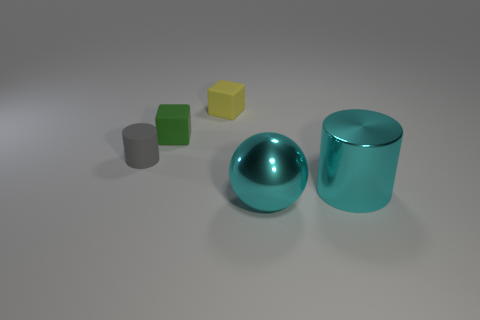The object that is to the right of the big cyan metallic object that is in front of the cylinder in front of the gray cylinder is what color?
Give a very brief answer. Cyan. Is the size of the ball the same as the gray cylinder?
Keep it short and to the point. No. How many other cyan shiny cylinders have the same size as the cyan cylinder?
Your answer should be very brief. 0. There is a large shiny object that is the same color as the large metallic cylinder; what is its shape?
Your answer should be compact. Sphere. Is the material of the cylinder that is to the right of the green object the same as the large cyan object on the left side of the large cylinder?
Offer a terse response. Yes. The large metallic ball is what color?
Your answer should be compact. Cyan. How many metal things are the same shape as the gray matte thing?
Your answer should be very brief. 1. There is another block that is the same size as the green rubber cube; what is its color?
Ensure brevity in your answer.  Yellow. Are any tiny blue matte cylinders visible?
Provide a short and direct response. No. What is the shape of the shiny thing in front of the big cylinder?
Your response must be concise. Sphere. 